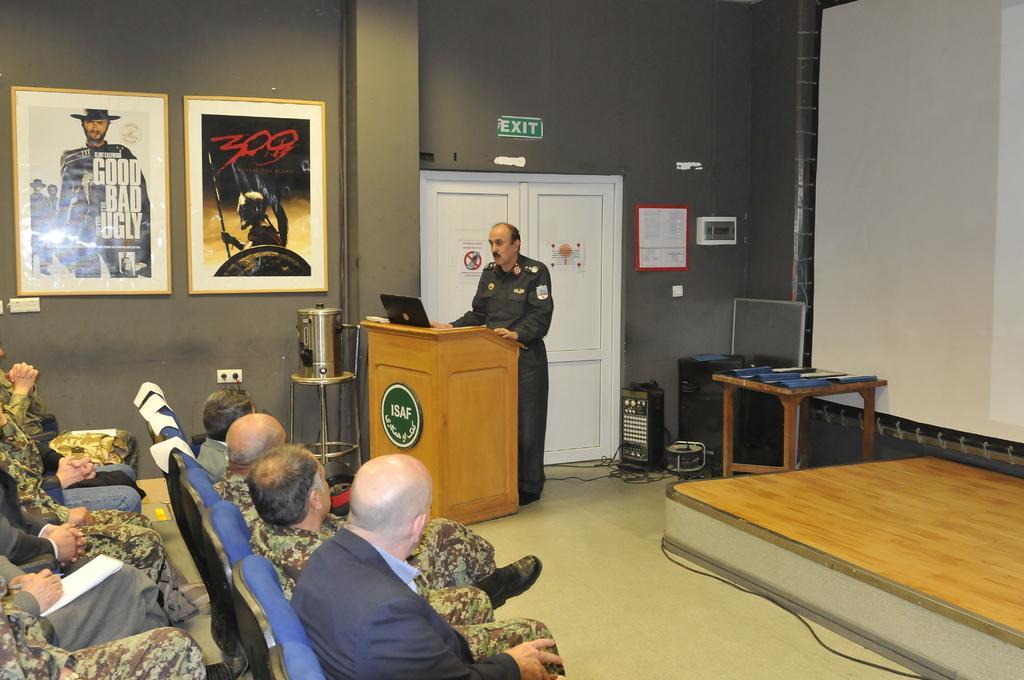In one or two sentences, can you explain what this image depicts? In this image i can see few people sitting on chair at the back ground i can see a man standing in front of the podium with a laptop, a screen , a frame attached to a wall and a door. 